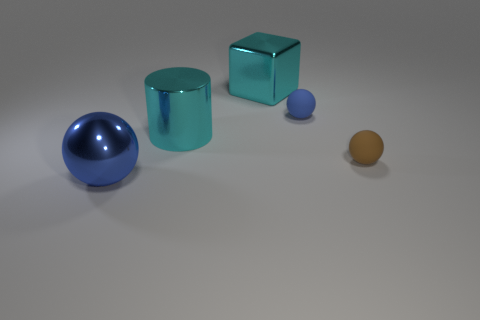There is a tiny rubber thing on the left side of the brown thing; is it the same color as the metal sphere?
Your answer should be compact. Yes. There is a tiny ball that is the same color as the large sphere; what material is it?
Offer a very short reply. Rubber. Are there more tiny brown balls that are behind the big cylinder than brown things?
Your answer should be very brief. No. What number of tiny brown rubber things are on the right side of the small object right of the blue object that is to the right of the metal cube?
Offer a very short reply. 0. The thing that is to the right of the large blue shiny sphere and in front of the cyan metallic cylinder is made of what material?
Provide a succinct answer. Rubber. What color is the shiny ball?
Offer a terse response. Blue. Are there more cyan cylinders that are in front of the cyan metal block than blue things in front of the small brown sphere?
Offer a very short reply. No. What color is the metallic thing that is behind the cyan cylinder?
Ensure brevity in your answer.  Cyan. Does the blue thing right of the blue metallic thing have the same size as the ball that is on the left side of the big cyan cube?
Provide a succinct answer. No. How many objects are blue matte spheres or big shiny objects?
Your answer should be compact. 4. 